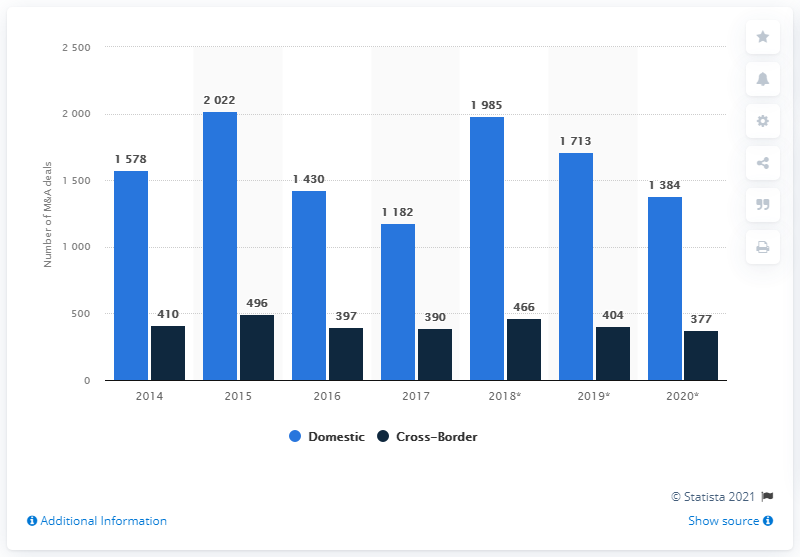Mention a couple of crucial points in this snapshot. In terms of merger and acquisition transactions, the activity with the highest number is domestic activities. In 2020, there were 377 cross-border merger and acquisition transactions in France. The use of dark blue color in the phrase "Cross-Border" indicates a sense of trust, reliability, and security. 